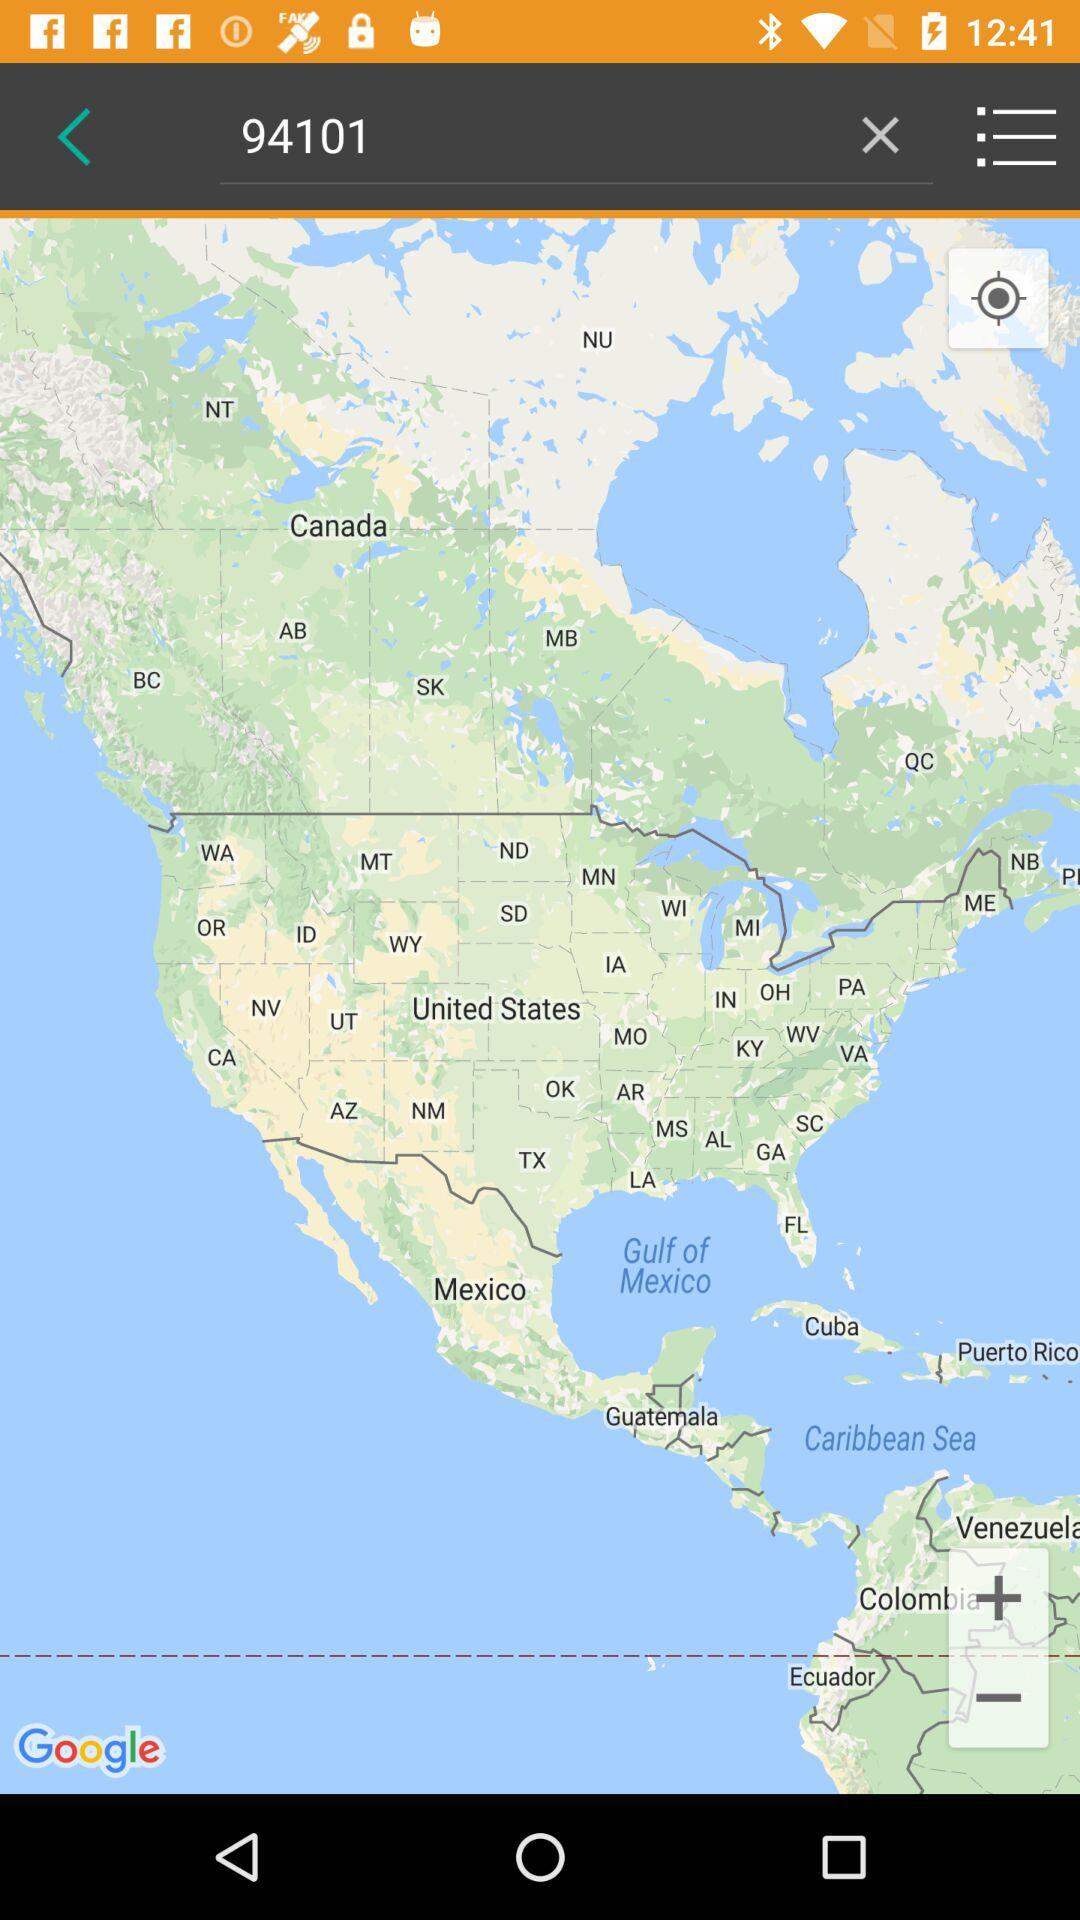Where does the user live?
When the provided information is insufficient, respond with <no answer>. <no answer> 